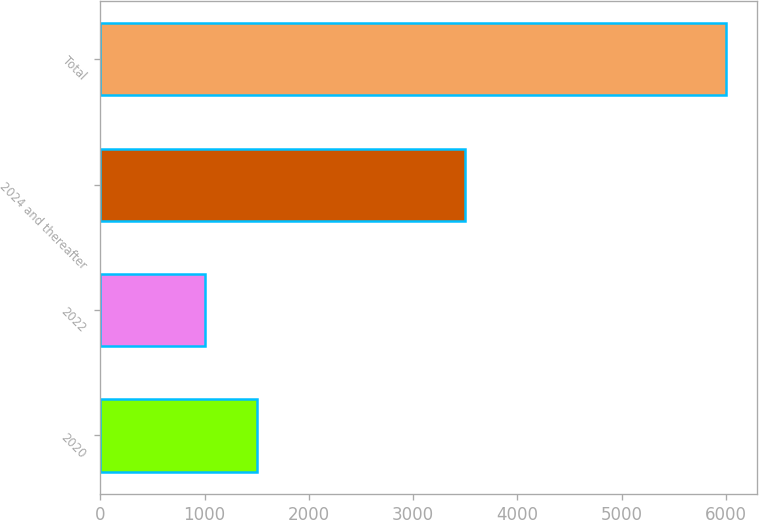<chart> <loc_0><loc_0><loc_500><loc_500><bar_chart><fcel>2020<fcel>2022<fcel>2024 and thereafter<fcel>Total<nl><fcel>1500<fcel>1000<fcel>3500<fcel>6000<nl></chart> 